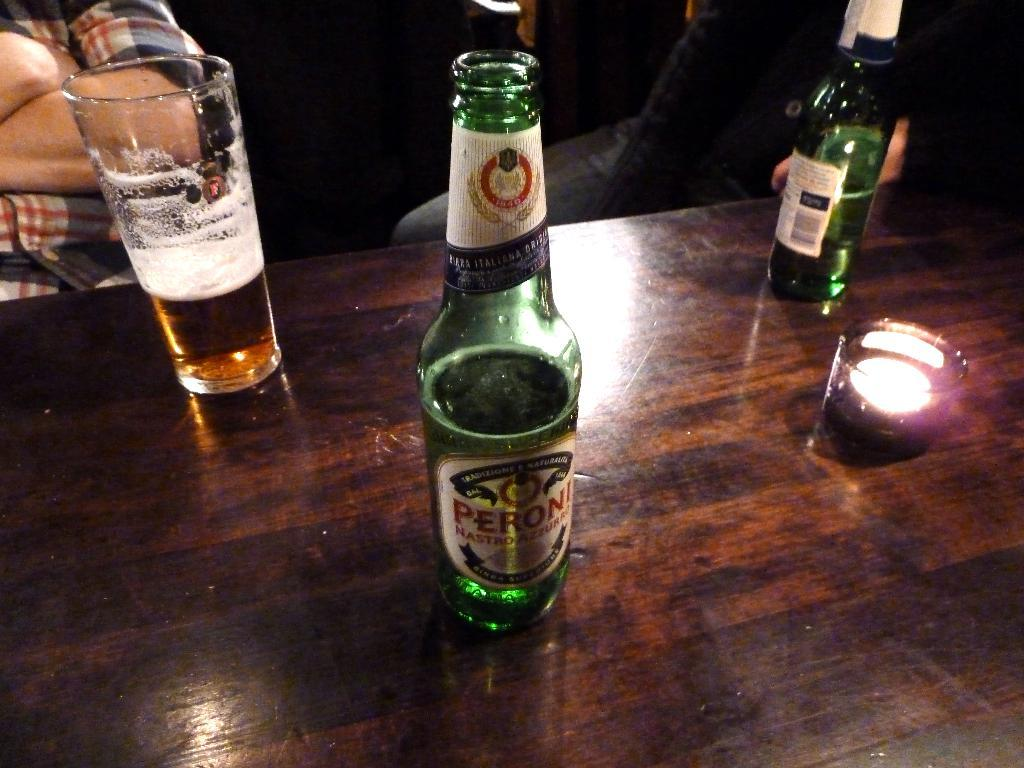What type of beverage containers can be seen on the table in the image? There are two wine bottles on the table. What other item is present on the table? There is a small candle bowl on the table. Is there any wine being consumed in the image? Yes, there is a glass with some wine on the table. How many people are in the image? There are two persons in the image. What type of organization does the skin of the person in the image belong to? There is no information about the person's skin or any organization in the image. What property is being discussed in the image? The image does not depict any property or property-related discussions. 